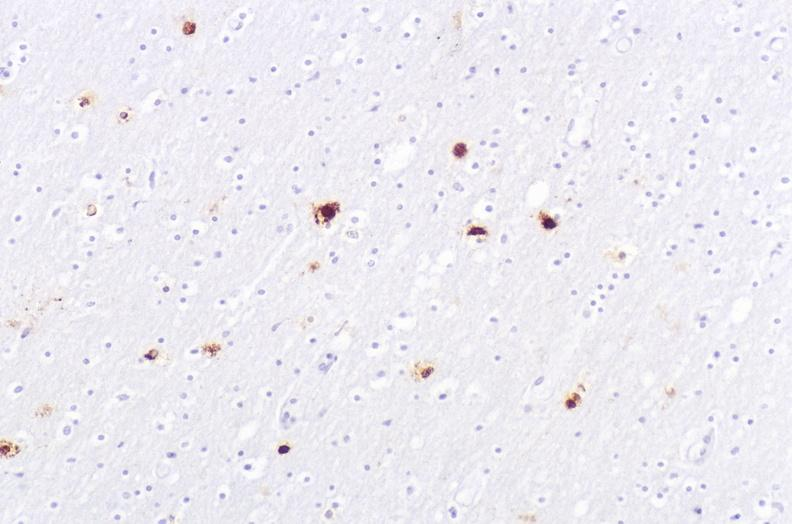does retroperitoneal liposarcoma show herpes simplex virus, brain, immunohistochemistry?
Answer the question using a single word or phrase. No 